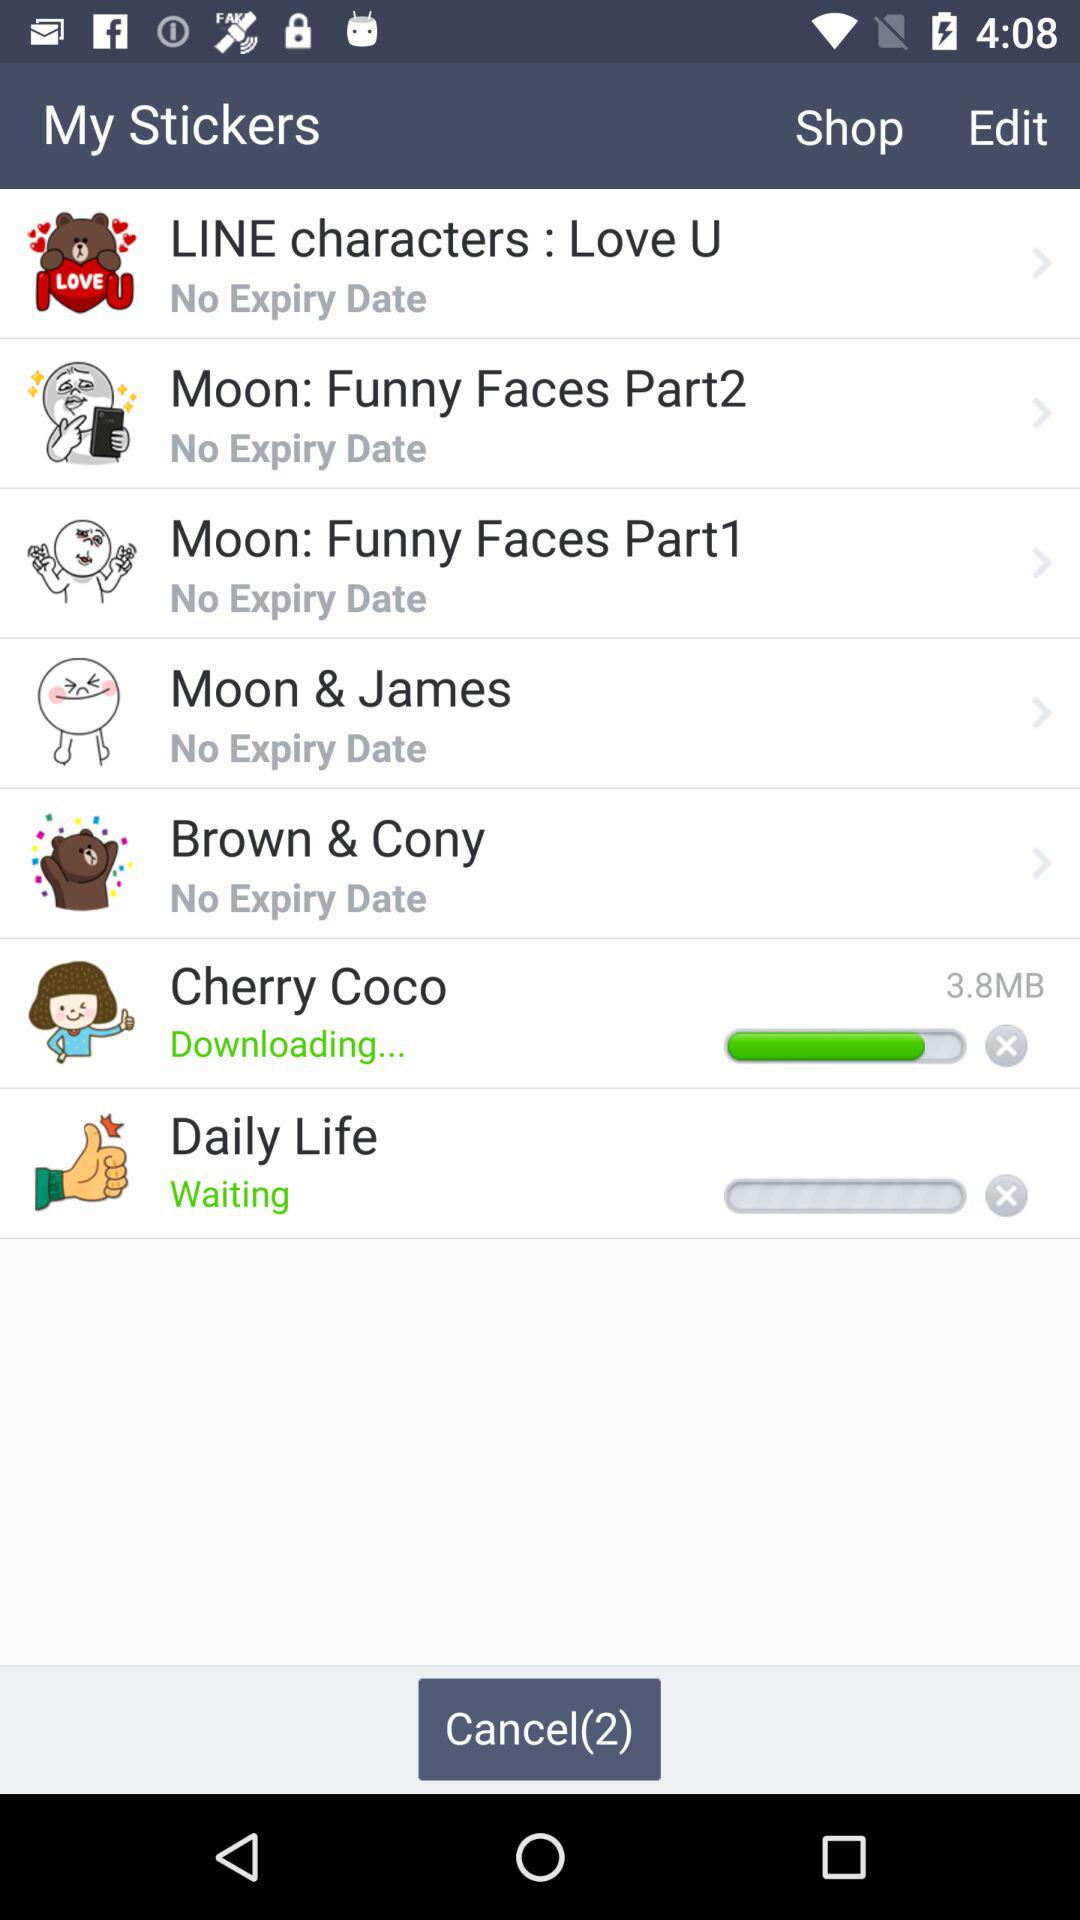How many items can be cancelled? The number of items that can be cancelled is 2. 